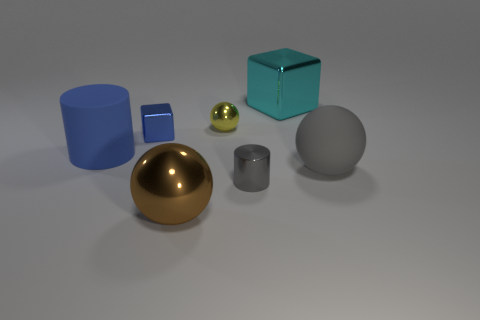How do the different materials of the objects in the image interact with the light? The materials display a variety of interactions with the light source. The gold sphere has a reflective, glossy surface that brightly mirrors the light, whereas the cyan and blue blocks exhibit a matte finish, diffusing the light softly. The gray metallic item in the center has a lustrous finish, producing both highlights and reflected light with more intensity than the matte surfaces but less than the gold sphere. The yellow sphere and the smaller silver cylinder also show reflectivity, with the yellow sphere casting a subtle sheen and the cylinder showcasing more defined reflections. 